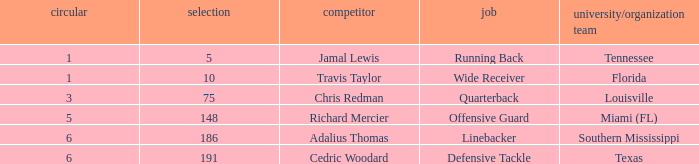Where's the first round that southern mississippi shows up during the draft? 6.0. 